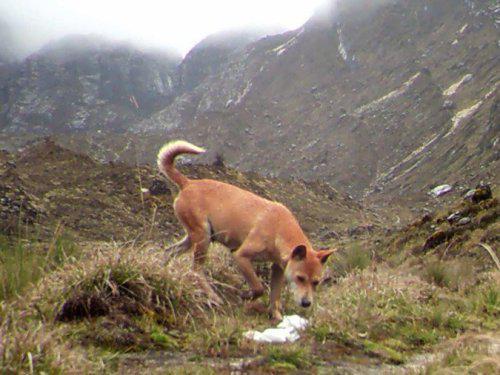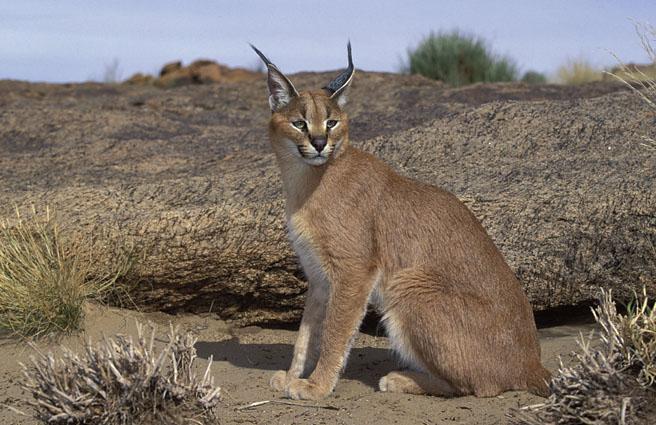The first image is the image on the left, the second image is the image on the right. For the images shown, is this caption "The image on the left shows two animals." true? Answer yes or no. No. The first image is the image on the left, the second image is the image on the right. For the images shown, is this caption "Each picture has 1 dog" true? Answer yes or no. No. 